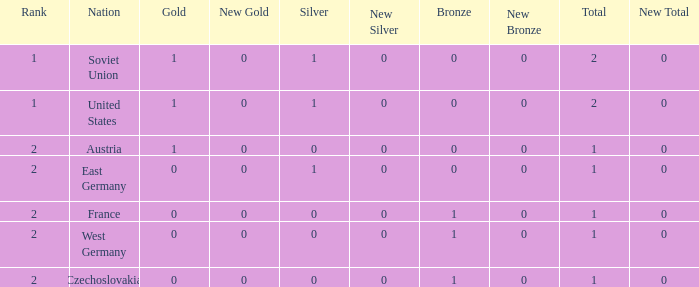What is the total number of bronze medals of West Germany, which is ranked 2 and has less than 1 total medals? 0.0. 